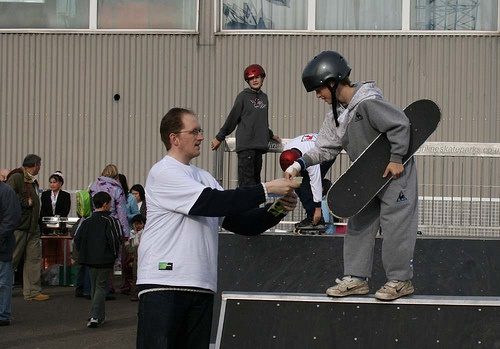Describe the objects in this image and their specific colors. I can see people in lightgray, black, lavender, and darkgray tones, people in lightgray, gray, black, and darkgray tones, people in lightgray, black, gray, darkgray, and lavender tones, people in lightgray, black, and gray tones, and skateboard in lightgray, black, gray, and darkgray tones in this image. 